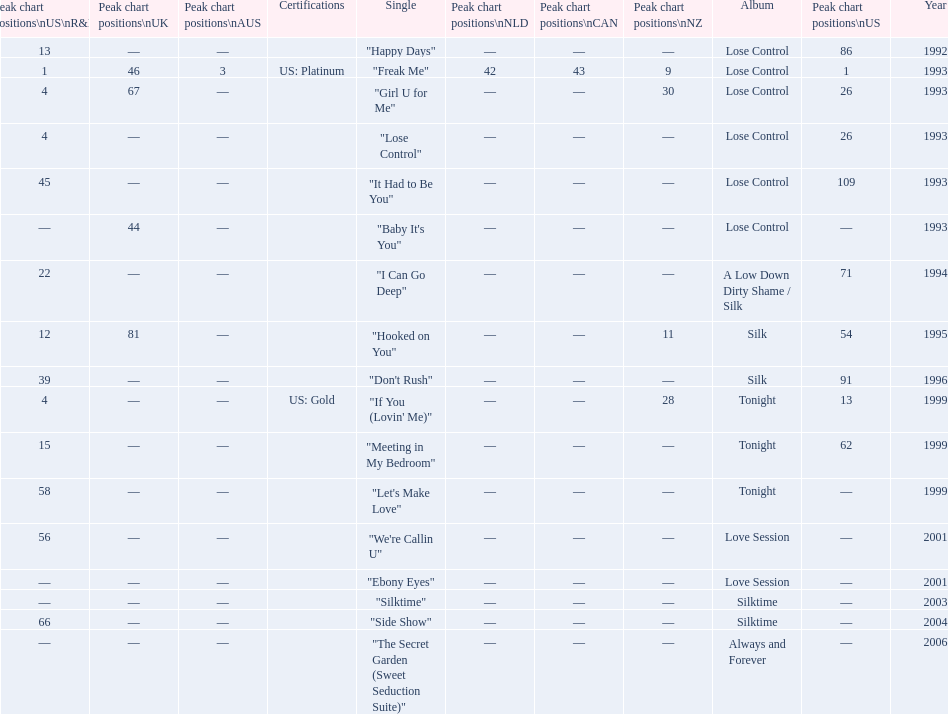Between "i can go deep" and "don't rush", which one had a higher position on the us and us r&b charts? "I Can Go Deep". 